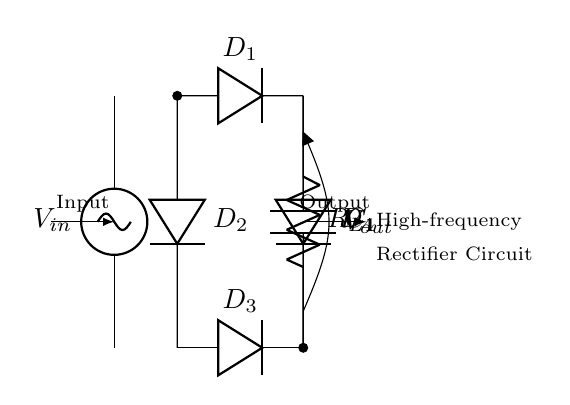What is the input voltage of the circuit? The input voltage is represented by the labeled component \(V_{in}\) in the circuit diagram, indicating it provides the necessary AC voltage to the rectifier.
Answer: \(V_{in}\) How many diodes are present in the circuit? The circuit shows a bridge rectifier configuration, typically composed of four diodes. You can count the diodes labeled \(D_1\), \(D_2\), \(D_3\), and \(D_4\).
Answer: 4 What is the purpose of capacitor \(C_1\)? Capacitor \(C_1\) is placed after the diodes and is used for smoothing the output voltage by filtering out ripple from the rectified output. This leads to a more stable DC output.
Answer: Smoothing What type of rectifier is represented in the diagram? The diagram illustrates a bridge rectifier, which is identified by the arrangement of four diodes forming a bridge to convert AC to DC efficiently, allowing for both halves of the AC signal to be utilized.
Answer: Bridge What is the load component in the circuit? The diagram specifies a load resistor labeled \(R_L\) connected to the output side of the smoothing capacitor. This component allows current to flow through it, representing the load that the rectifier will supply power to.
Answer: \(R_L\) Explain how diodes function together in this circuit. The four diodes in the bridge configuration work in pairs: during the positive cycle of the AC input, \(D_1\) and \(D_2\) conduct, allowing current to pass to \(R_L\). During the negative cycle, \(D_3\) and \(D_4\) conduct in the opposite direction, maintaining the current flow in the same direction through the load. This enables both halves of the AC waveform to contribute to the DC output.
Answer: Conduct in pairs What is the expected output polarity of the rectifier? The output voltage \(V_{out}\) is taken from the junction of the diodes with respect to ground, indicating that this is a positive polarity output for the load \(R_L\), as both halves of the AC waveform are utilized to produce a continuous positive voltage.
Answer: Positive 